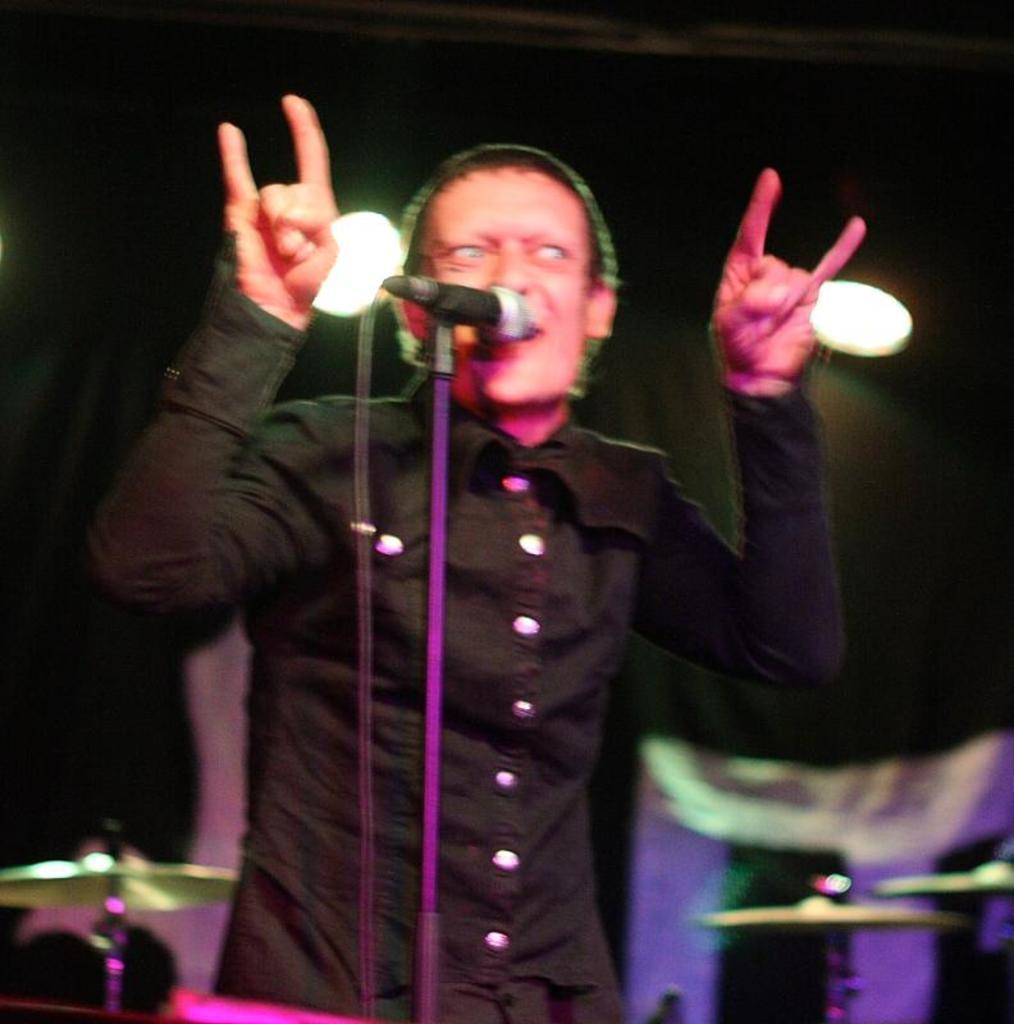Could you give a brief overview of what you see in this image? In this picture there is a person who is standing at the center of the image, he is singing in the mic and there are spotlights above the area of the image and there is drum set at the right and left side of the image. 